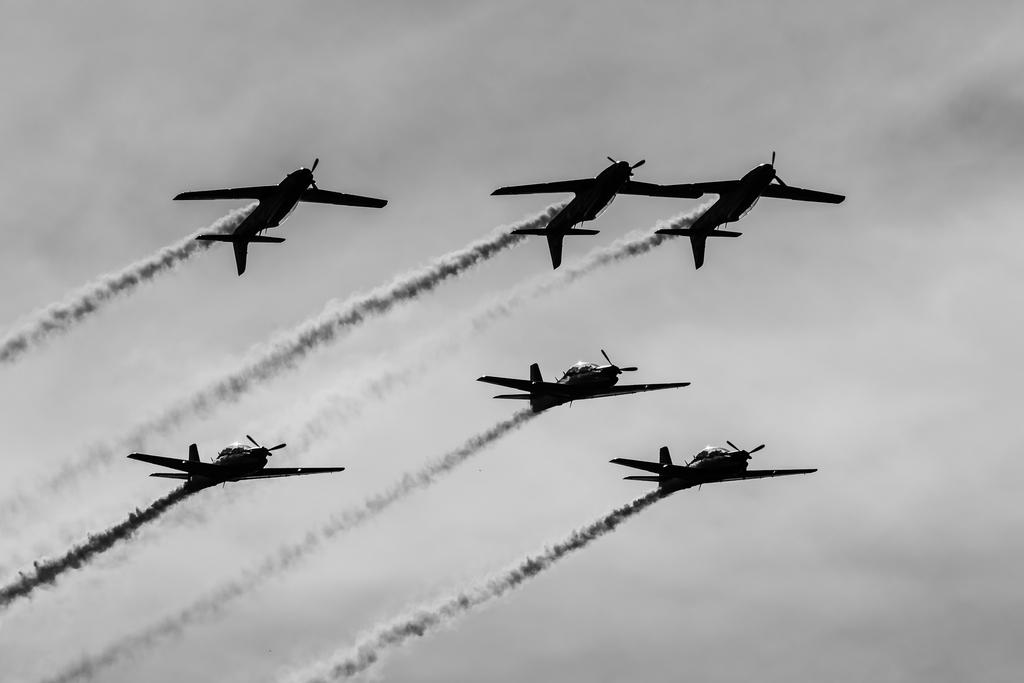What is happening in the sky in the image? There are planes flying in the air in the image. What is the color scheme of the image? The image is black and white. Can you see any sea creatures swimming in the hole in the image? There is no sea or hole present in the image; it features planes flying in the air in a black and white color scheme. 